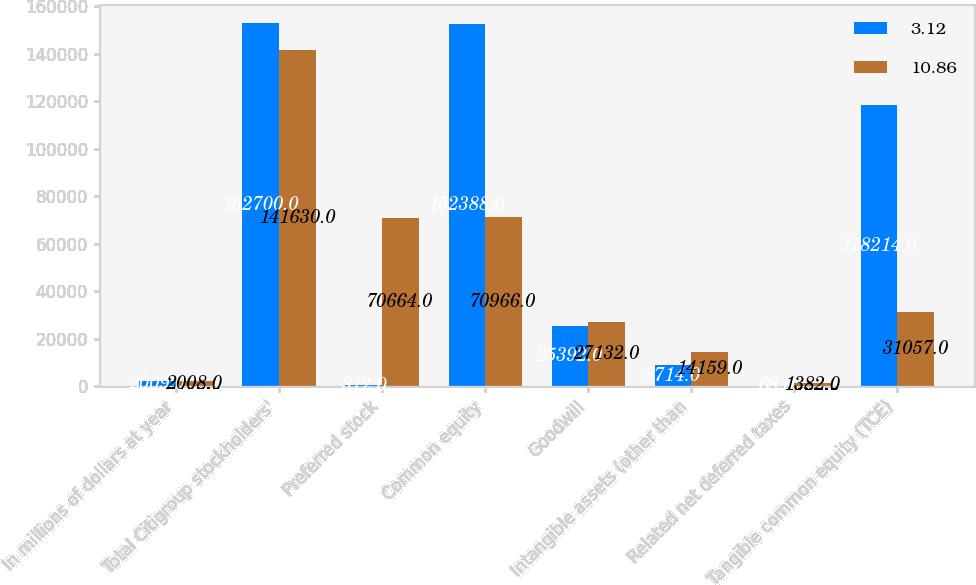Convert chart to OTSL. <chart><loc_0><loc_0><loc_500><loc_500><stacked_bar_chart><ecel><fcel>In millions of dollars at year<fcel>Total Citigroup stockholders'<fcel>Preferred stock<fcel>Common equity<fcel>Goodwill<fcel>Intangible assets (other than<fcel>Related net deferred taxes<fcel>Tangible common equity (TCE)<nl><fcel>3.12<fcel>2009<fcel>152700<fcel>312<fcel>152388<fcel>25392<fcel>8714<fcel>68<fcel>118214<nl><fcel>10.86<fcel>2008<fcel>141630<fcel>70664<fcel>70966<fcel>27132<fcel>14159<fcel>1382<fcel>31057<nl></chart> 